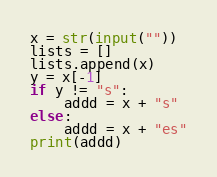<code> <loc_0><loc_0><loc_500><loc_500><_Python_>x = str(input(""))
lists = []
lists.append(x)
y = x[-1]
if y != "s":
    addd = x + "s"
else:
    addd = x + "es"
print(addd)</code> 